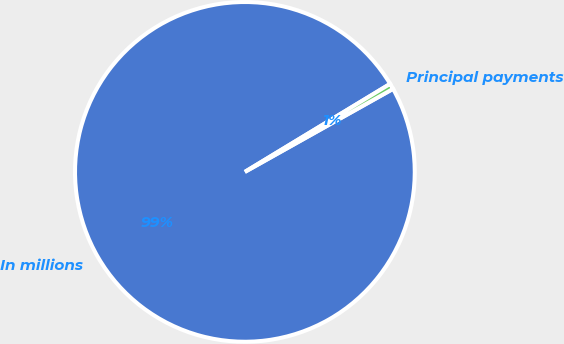Convert chart. <chart><loc_0><loc_0><loc_500><loc_500><pie_chart><fcel>In millions<fcel>Principal payments<nl><fcel>99.46%<fcel>0.54%<nl></chart> 